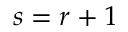<formula> <loc_0><loc_0><loc_500><loc_500>s = r + 1</formula> 